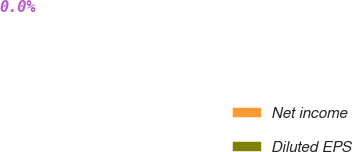<chart> <loc_0><loc_0><loc_500><loc_500><pie_chart><fcel>Net income<fcel>Diluted EPS<nl><fcel>100.0%<fcel>0.0%<nl></chart> 